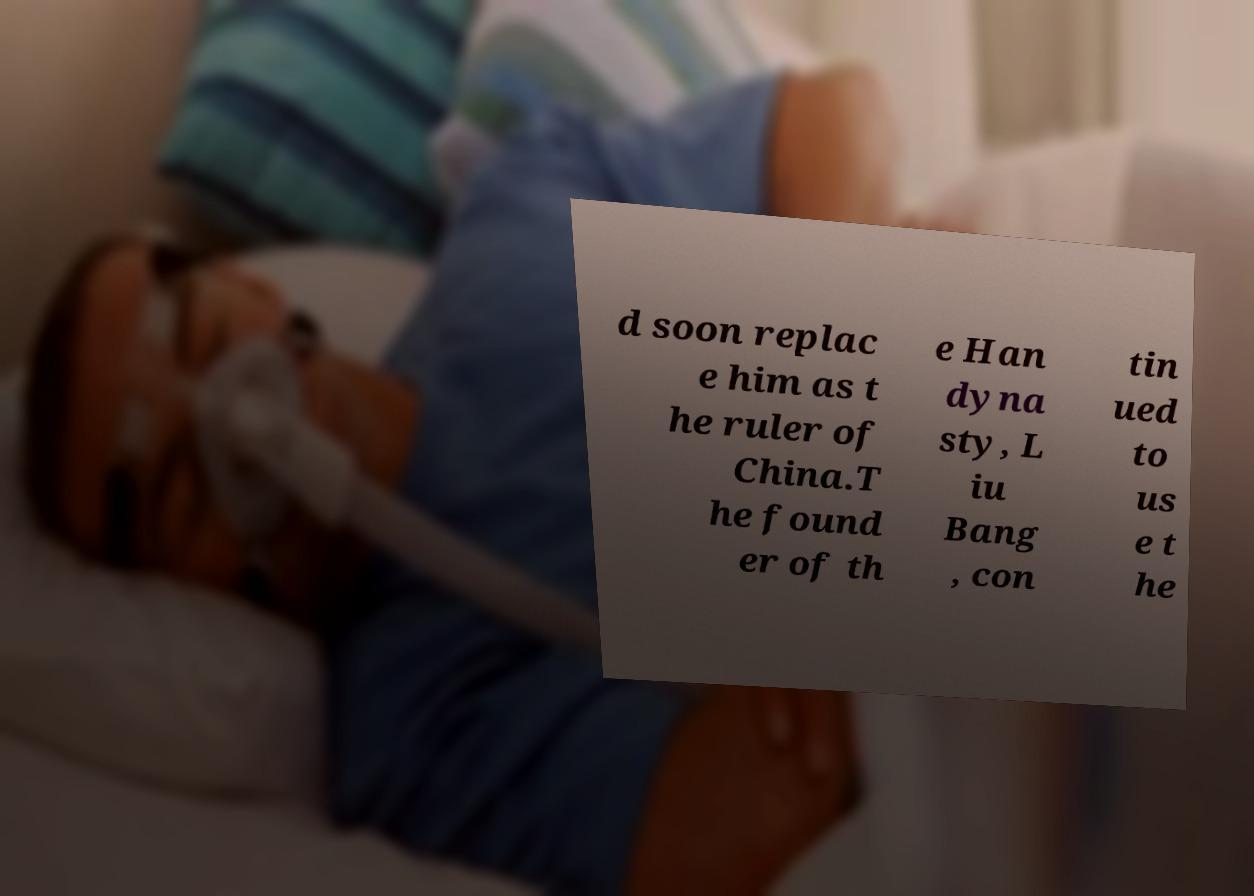Could you assist in decoding the text presented in this image and type it out clearly? d soon replac e him as t he ruler of China.T he found er of th e Han dyna sty, L iu Bang , con tin ued to us e t he 